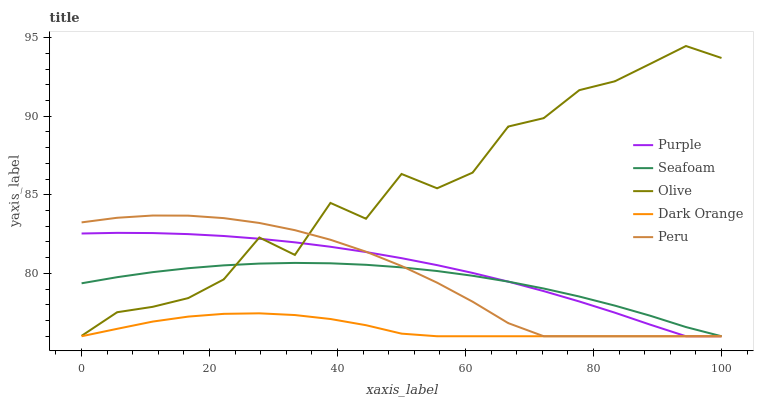Does Dark Orange have the minimum area under the curve?
Answer yes or no. Yes. Does Olive have the maximum area under the curve?
Answer yes or no. Yes. Does Seafoam have the minimum area under the curve?
Answer yes or no. No. Does Seafoam have the maximum area under the curve?
Answer yes or no. No. Is Seafoam the smoothest?
Answer yes or no. Yes. Is Olive the roughest?
Answer yes or no. Yes. Is Olive the smoothest?
Answer yes or no. No. Is Seafoam the roughest?
Answer yes or no. No. Does Olive have the lowest value?
Answer yes or no. No. Does Olive have the highest value?
Answer yes or no. Yes. Does Seafoam have the highest value?
Answer yes or no. No. Is Dark Orange less than Olive?
Answer yes or no. Yes. Is Olive greater than Dark Orange?
Answer yes or no. Yes. Does Olive intersect Peru?
Answer yes or no. Yes. Is Olive less than Peru?
Answer yes or no. No. Is Olive greater than Peru?
Answer yes or no. No. Does Dark Orange intersect Olive?
Answer yes or no. No. 